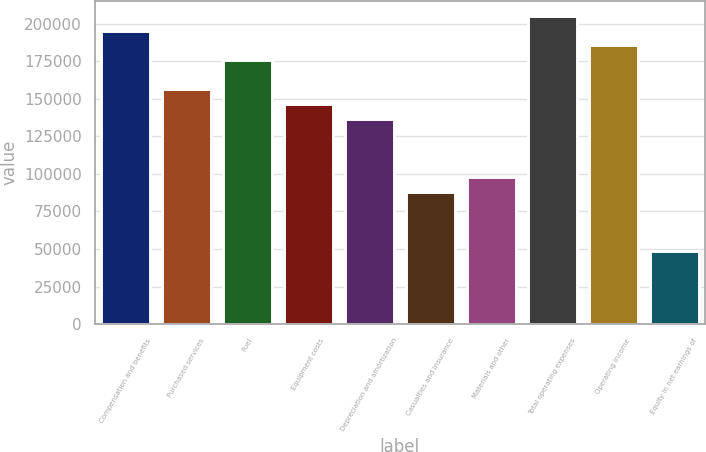<chart> <loc_0><loc_0><loc_500><loc_500><bar_chart><fcel>Compensation and benefits<fcel>Purchased services<fcel>Fuel<fcel>Equipment costs<fcel>Depreciation and amortization<fcel>Casualties and insurance<fcel>Materials and other<fcel>Total operating expenses<fcel>Operating income<fcel>Equity in net earnings of<nl><fcel>195232<fcel>156185<fcel>175708<fcel>146424<fcel>136662<fcel>87854.4<fcel>97616<fcel>204993<fcel>185470<fcel>48808.2<nl></chart> 